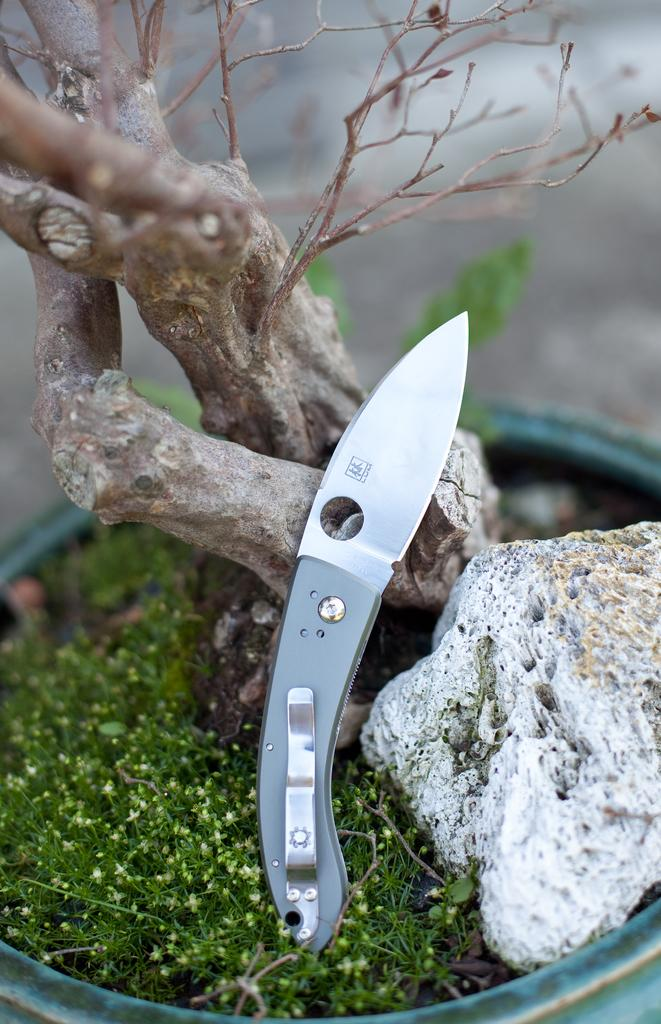What type of natural element can be seen in the image? There is a tree in the image. What other object can be seen in the image? There is a rock in the image. What man-made object is present in the image? There is a knife in the image. What type of vegetation is present in the image? There are plants to the side in the image. In which direction does the grass grow in the image? There is no grass present in the image, so it is not possible to determine the direction of its growth. 